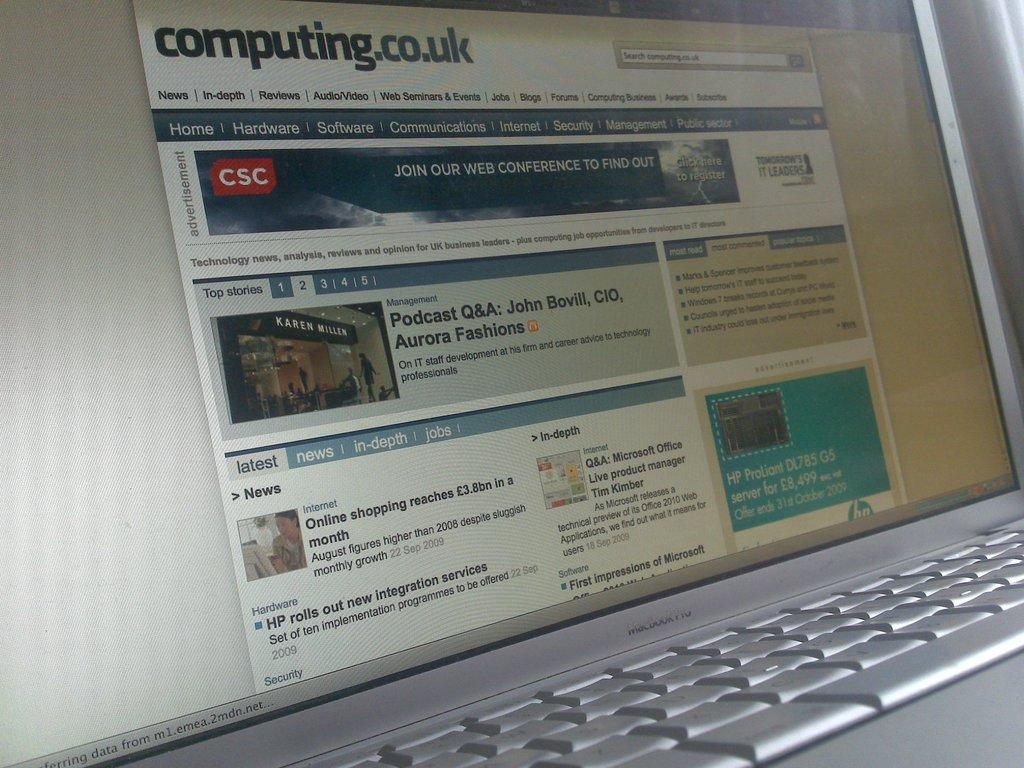<image>
Share a concise interpretation of the image provided. An open laptop is open to a computing.co.uk webpage. 